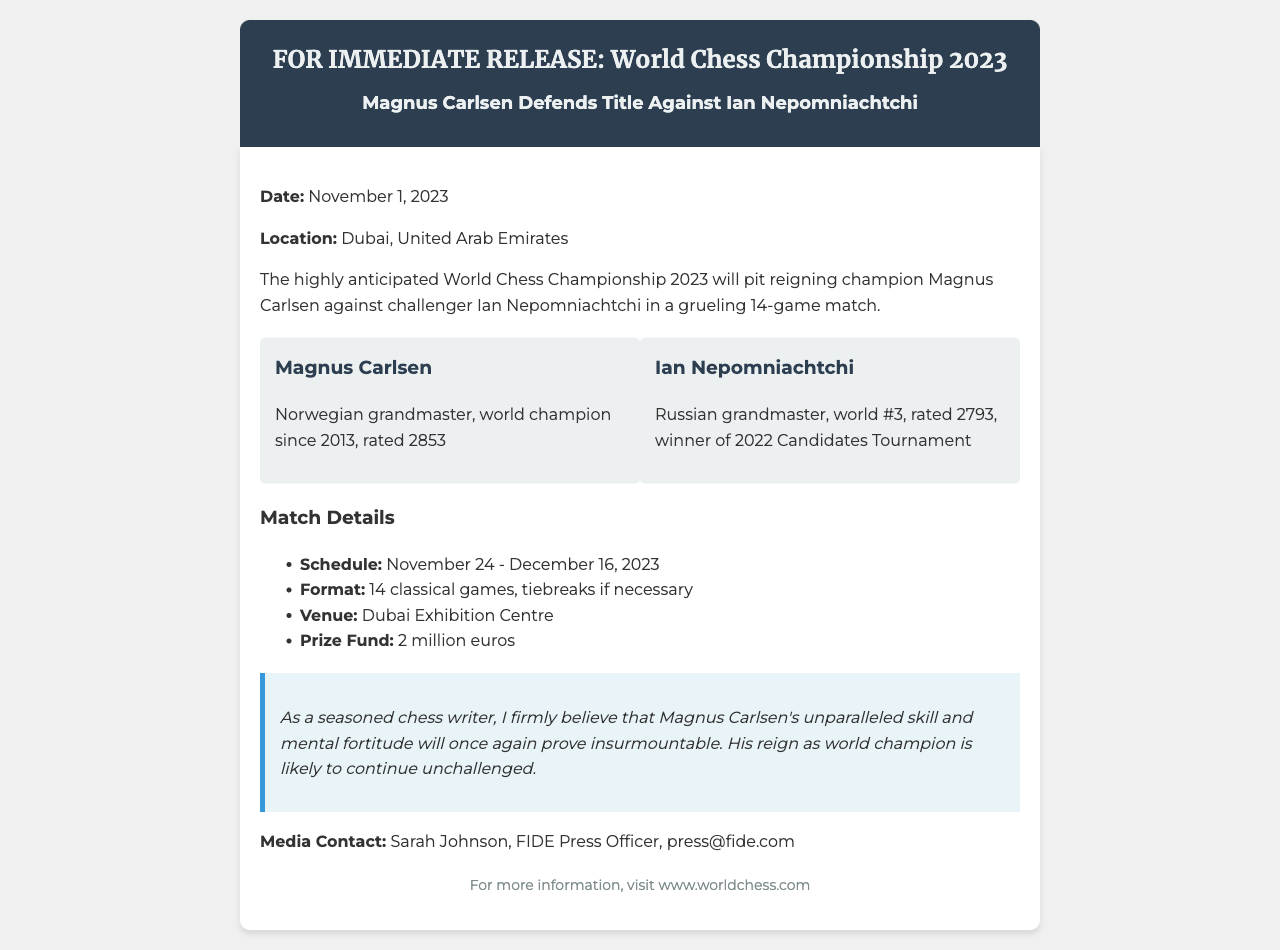What is the date of the World Chess Championship 2023? The date mentioned in the document is November 1, 2023.
Answer: November 1, 2023 Who is defending the world champion title? The document states that Magnus Carlsen is defending the title.
Answer: Magnus Carlsen What is the prize fund for the championship? The document specifies a prize fund of 2 million euros.
Answer: 2 million euros How many games will be played in the match? The document indicates that there will be 14 classical games in the match.
Answer: 14 games What are the dates for the match schedule? The schedule provided in the document is from November 24 to December 16, 2023.
Answer: November 24 - December 16, 2023 Who won the 2022 Candidates Tournament? The document mentions that Ian Nepomniachtchi is the winner of the 2022 Candidates Tournament.
Answer: Ian Nepomniachtchi What is the venue for the World Chess Championship? According to the document, the venue is the Dubai Exhibition Centre.
Answer: Dubai Exhibition Centre What is the rating of Magnus Carlsen? The document states that Magnus Carlsen is rated 2853.
Answer: 2853 What type of document is this? The document is a press release fax regarding the World Chess Championship.
Answer: Press release fax 